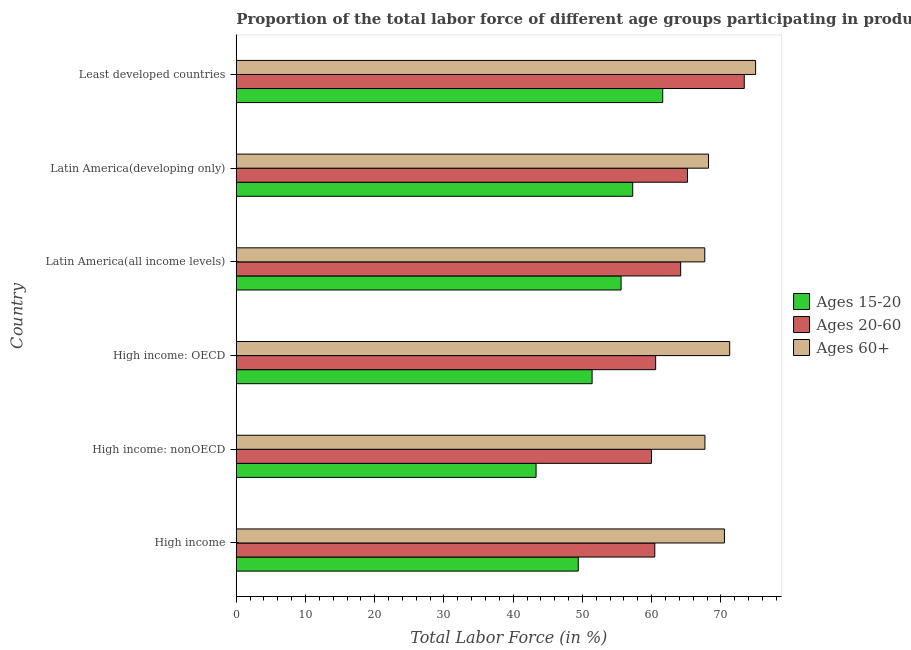How many groups of bars are there?
Offer a terse response. 6. Are the number of bars per tick equal to the number of legend labels?
Give a very brief answer. Yes. How many bars are there on the 3rd tick from the top?
Your response must be concise. 3. How many bars are there on the 6th tick from the bottom?
Offer a terse response. 3. What is the label of the 5th group of bars from the top?
Offer a very short reply. High income: nonOECD. In how many cases, is the number of bars for a given country not equal to the number of legend labels?
Provide a short and direct response. 0. What is the percentage of labor force above age 60 in Latin America(all income levels)?
Your response must be concise. 67.67. Across all countries, what is the maximum percentage of labor force within the age group 15-20?
Provide a succinct answer. 61.6. Across all countries, what is the minimum percentage of labor force within the age group 15-20?
Ensure brevity in your answer.  43.31. In which country was the percentage of labor force within the age group 15-20 maximum?
Your answer should be compact. Least developed countries. In which country was the percentage of labor force within the age group 15-20 minimum?
Ensure brevity in your answer.  High income: nonOECD. What is the total percentage of labor force above age 60 in the graph?
Provide a succinct answer. 420.39. What is the difference between the percentage of labor force above age 60 in Latin America(all income levels) and that in Least developed countries?
Provide a short and direct response. -7.34. What is the difference between the percentage of labor force within the age group 15-20 in High income and the percentage of labor force within the age group 20-60 in High income: nonOECD?
Your response must be concise. -10.57. What is the average percentage of labor force within the age group 20-60 per country?
Your response must be concise. 63.96. What is the difference between the percentage of labor force within the age group 20-60 and percentage of labor force within the age group 15-20 in Latin America(all income levels)?
Ensure brevity in your answer.  8.61. In how many countries, is the percentage of labor force within the age group 15-20 greater than 2 %?
Ensure brevity in your answer.  6. What is the ratio of the percentage of labor force within the age group 20-60 in High income: nonOECD to that in Latin America(all income levels)?
Offer a terse response. 0.93. What is the difference between the highest and the second highest percentage of labor force within the age group 15-20?
Offer a very short reply. 4.33. What is the difference between the highest and the lowest percentage of labor force above age 60?
Make the answer very short. 7.34. In how many countries, is the percentage of labor force within the age group 20-60 greater than the average percentage of labor force within the age group 20-60 taken over all countries?
Offer a terse response. 3. Is the sum of the percentage of labor force above age 60 in High income: nonOECD and Least developed countries greater than the maximum percentage of labor force within the age group 15-20 across all countries?
Provide a short and direct response. Yes. What does the 3rd bar from the top in High income: OECD represents?
Provide a short and direct response. Ages 15-20. What does the 2nd bar from the bottom in Latin America(developing only) represents?
Provide a succinct answer. Ages 20-60. Is it the case that in every country, the sum of the percentage of labor force within the age group 15-20 and percentage of labor force within the age group 20-60 is greater than the percentage of labor force above age 60?
Provide a succinct answer. Yes. How many countries are there in the graph?
Offer a terse response. 6. What is the difference between two consecutive major ticks on the X-axis?
Your response must be concise. 10. Are the values on the major ticks of X-axis written in scientific E-notation?
Ensure brevity in your answer.  No. Does the graph contain any zero values?
Keep it short and to the point. No. Does the graph contain grids?
Keep it short and to the point. No. Where does the legend appear in the graph?
Ensure brevity in your answer.  Center right. How many legend labels are there?
Give a very brief answer. 3. What is the title of the graph?
Keep it short and to the point. Proportion of the total labor force of different age groups participating in production in 1999. Does "Taxes on goods and services" appear as one of the legend labels in the graph?
Offer a very short reply. No. What is the label or title of the X-axis?
Your response must be concise. Total Labor Force (in %). What is the Total Labor Force (in %) in Ages 15-20 in High income?
Provide a succinct answer. 49.4. What is the Total Labor Force (in %) of Ages 20-60 in High income?
Your answer should be very brief. 60.46. What is the Total Labor Force (in %) of Ages 60+ in High income?
Ensure brevity in your answer.  70.51. What is the Total Labor Force (in %) in Ages 15-20 in High income: nonOECD?
Your answer should be very brief. 43.31. What is the Total Labor Force (in %) in Ages 20-60 in High income: nonOECD?
Provide a short and direct response. 59.97. What is the Total Labor Force (in %) of Ages 60+ in High income: nonOECD?
Provide a short and direct response. 67.7. What is the Total Labor Force (in %) of Ages 15-20 in High income: OECD?
Make the answer very short. 51.4. What is the Total Labor Force (in %) in Ages 20-60 in High income: OECD?
Provide a succinct answer. 60.58. What is the Total Labor Force (in %) in Ages 60+ in High income: OECD?
Offer a very short reply. 71.27. What is the Total Labor Force (in %) in Ages 15-20 in Latin America(all income levels)?
Your response must be concise. 55.59. What is the Total Labor Force (in %) of Ages 20-60 in Latin America(all income levels)?
Provide a succinct answer. 64.19. What is the Total Labor Force (in %) of Ages 60+ in Latin America(all income levels)?
Ensure brevity in your answer.  67.67. What is the Total Labor Force (in %) in Ages 15-20 in Latin America(developing only)?
Keep it short and to the point. 57.26. What is the Total Labor Force (in %) in Ages 20-60 in Latin America(developing only)?
Your response must be concise. 65.18. What is the Total Labor Force (in %) of Ages 60+ in Latin America(developing only)?
Make the answer very short. 68.22. What is the Total Labor Force (in %) in Ages 15-20 in Least developed countries?
Offer a terse response. 61.6. What is the Total Labor Force (in %) in Ages 20-60 in Least developed countries?
Offer a terse response. 73.38. What is the Total Labor Force (in %) in Ages 60+ in Least developed countries?
Give a very brief answer. 75.02. Across all countries, what is the maximum Total Labor Force (in %) in Ages 15-20?
Give a very brief answer. 61.6. Across all countries, what is the maximum Total Labor Force (in %) in Ages 20-60?
Give a very brief answer. 73.38. Across all countries, what is the maximum Total Labor Force (in %) in Ages 60+?
Provide a succinct answer. 75.02. Across all countries, what is the minimum Total Labor Force (in %) of Ages 15-20?
Ensure brevity in your answer.  43.31. Across all countries, what is the minimum Total Labor Force (in %) of Ages 20-60?
Ensure brevity in your answer.  59.97. Across all countries, what is the minimum Total Labor Force (in %) in Ages 60+?
Provide a short and direct response. 67.67. What is the total Total Labor Force (in %) in Ages 15-20 in the graph?
Give a very brief answer. 318.57. What is the total Total Labor Force (in %) in Ages 20-60 in the graph?
Provide a succinct answer. 383.77. What is the total Total Labor Force (in %) of Ages 60+ in the graph?
Your answer should be compact. 420.39. What is the difference between the Total Labor Force (in %) of Ages 15-20 in High income and that in High income: nonOECD?
Give a very brief answer. 6.09. What is the difference between the Total Labor Force (in %) of Ages 20-60 in High income and that in High income: nonOECD?
Make the answer very short. 0.48. What is the difference between the Total Labor Force (in %) of Ages 60+ in High income and that in High income: nonOECD?
Offer a very short reply. 2.82. What is the difference between the Total Labor Force (in %) in Ages 15-20 in High income and that in High income: OECD?
Make the answer very short. -2. What is the difference between the Total Labor Force (in %) in Ages 20-60 in High income and that in High income: OECD?
Give a very brief answer. -0.12. What is the difference between the Total Labor Force (in %) in Ages 60+ in High income and that in High income: OECD?
Make the answer very short. -0.76. What is the difference between the Total Labor Force (in %) of Ages 15-20 in High income and that in Latin America(all income levels)?
Ensure brevity in your answer.  -6.19. What is the difference between the Total Labor Force (in %) of Ages 20-60 in High income and that in Latin America(all income levels)?
Offer a terse response. -3.74. What is the difference between the Total Labor Force (in %) of Ages 60+ in High income and that in Latin America(all income levels)?
Offer a terse response. 2.84. What is the difference between the Total Labor Force (in %) in Ages 15-20 in High income and that in Latin America(developing only)?
Offer a terse response. -7.86. What is the difference between the Total Labor Force (in %) of Ages 20-60 in High income and that in Latin America(developing only)?
Give a very brief answer. -4.73. What is the difference between the Total Labor Force (in %) of Ages 60+ in High income and that in Latin America(developing only)?
Make the answer very short. 2.3. What is the difference between the Total Labor Force (in %) in Ages 15-20 in High income and that in Least developed countries?
Your answer should be compact. -12.2. What is the difference between the Total Labor Force (in %) in Ages 20-60 in High income and that in Least developed countries?
Your answer should be very brief. -12.92. What is the difference between the Total Labor Force (in %) of Ages 60+ in High income and that in Least developed countries?
Your answer should be very brief. -4.5. What is the difference between the Total Labor Force (in %) of Ages 15-20 in High income: nonOECD and that in High income: OECD?
Offer a very short reply. -8.09. What is the difference between the Total Labor Force (in %) of Ages 20-60 in High income: nonOECD and that in High income: OECD?
Keep it short and to the point. -0.61. What is the difference between the Total Labor Force (in %) in Ages 60+ in High income: nonOECD and that in High income: OECD?
Offer a very short reply. -3.58. What is the difference between the Total Labor Force (in %) in Ages 15-20 in High income: nonOECD and that in Latin America(all income levels)?
Offer a very short reply. -12.28. What is the difference between the Total Labor Force (in %) of Ages 20-60 in High income: nonOECD and that in Latin America(all income levels)?
Your answer should be very brief. -4.22. What is the difference between the Total Labor Force (in %) of Ages 60+ in High income: nonOECD and that in Latin America(all income levels)?
Offer a terse response. 0.02. What is the difference between the Total Labor Force (in %) of Ages 15-20 in High income: nonOECD and that in Latin America(developing only)?
Ensure brevity in your answer.  -13.96. What is the difference between the Total Labor Force (in %) of Ages 20-60 in High income: nonOECD and that in Latin America(developing only)?
Your response must be concise. -5.21. What is the difference between the Total Labor Force (in %) in Ages 60+ in High income: nonOECD and that in Latin America(developing only)?
Make the answer very short. -0.52. What is the difference between the Total Labor Force (in %) of Ages 15-20 in High income: nonOECD and that in Least developed countries?
Ensure brevity in your answer.  -18.29. What is the difference between the Total Labor Force (in %) of Ages 20-60 in High income: nonOECD and that in Least developed countries?
Your answer should be compact. -13.41. What is the difference between the Total Labor Force (in %) of Ages 60+ in High income: nonOECD and that in Least developed countries?
Give a very brief answer. -7.32. What is the difference between the Total Labor Force (in %) of Ages 15-20 in High income: OECD and that in Latin America(all income levels)?
Give a very brief answer. -4.19. What is the difference between the Total Labor Force (in %) in Ages 20-60 in High income: OECD and that in Latin America(all income levels)?
Your response must be concise. -3.62. What is the difference between the Total Labor Force (in %) of Ages 60+ in High income: OECD and that in Latin America(all income levels)?
Your answer should be very brief. 3.6. What is the difference between the Total Labor Force (in %) of Ages 15-20 in High income: OECD and that in Latin America(developing only)?
Make the answer very short. -5.86. What is the difference between the Total Labor Force (in %) in Ages 20-60 in High income: OECD and that in Latin America(developing only)?
Your response must be concise. -4.6. What is the difference between the Total Labor Force (in %) of Ages 60+ in High income: OECD and that in Latin America(developing only)?
Ensure brevity in your answer.  3.06. What is the difference between the Total Labor Force (in %) in Ages 15-20 in High income: OECD and that in Least developed countries?
Provide a short and direct response. -10.2. What is the difference between the Total Labor Force (in %) in Ages 20-60 in High income: OECD and that in Least developed countries?
Keep it short and to the point. -12.8. What is the difference between the Total Labor Force (in %) of Ages 60+ in High income: OECD and that in Least developed countries?
Offer a terse response. -3.74. What is the difference between the Total Labor Force (in %) in Ages 15-20 in Latin America(all income levels) and that in Latin America(developing only)?
Keep it short and to the point. -1.68. What is the difference between the Total Labor Force (in %) in Ages 20-60 in Latin America(all income levels) and that in Latin America(developing only)?
Ensure brevity in your answer.  -0.99. What is the difference between the Total Labor Force (in %) of Ages 60+ in Latin America(all income levels) and that in Latin America(developing only)?
Your answer should be very brief. -0.54. What is the difference between the Total Labor Force (in %) of Ages 15-20 in Latin America(all income levels) and that in Least developed countries?
Provide a succinct answer. -6.01. What is the difference between the Total Labor Force (in %) in Ages 20-60 in Latin America(all income levels) and that in Least developed countries?
Your response must be concise. -9.19. What is the difference between the Total Labor Force (in %) of Ages 60+ in Latin America(all income levels) and that in Least developed countries?
Your response must be concise. -7.34. What is the difference between the Total Labor Force (in %) of Ages 15-20 in Latin America(developing only) and that in Least developed countries?
Give a very brief answer. -4.34. What is the difference between the Total Labor Force (in %) of Ages 20-60 in Latin America(developing only) and that in Least developed countries?
Make the answer very short. -8.2. What is the difference between the Total Labor Force (in %) of Ages 60+ in Latin America(developing only) and that in Least developed countries?
Offer a very short reply. -6.8. What is the difference between the Total Labor Force (in %) in Ages 15-20 in High income and the Total Labor Force (in %) in Ages 20-60 in High income: nonOECD?
Your answer should be very brief. -10.57. What is the difference between the Total Labor Force (in %) in Ages 15-20 in High income and the Total Labor Force (in %) in Ages 60+ in High income: nonOECD?
Offer a terse response. -18.29. What is the difference between the Total Labor Force (in %) in Ages 20-60 in High income and the Total Labor Force (in %) in Ages 60+ in High income: nonOECD?
Keep it short and to the point. -7.24. What is the difference between the Total Labor Force (in %) of Ages 15-20 in High income and the Total Labor Force (in %) of Ages 20-60 in High income: OECD?
Offer a very short reply. -11.18. What is the difference between the Total Labor Force (in %) of Ages 15-20 in High income and the Total Labor Force (in %) of Ages 60+ in High income: OECD?
Make the answer very short. -21.87. What is the difference between the Total Labor Force (in %) of Ages 20-60 in High income and the Total Labor Force (in %) of Ages 60+ in High income: OECD?
Your answer should be very brief. -10.82. What is the difference between the Total Labor Force (in %) of Ages 15-20 in High income and the Total Labor Force (in %) of Ages 20-60 in Latin America(all income levels)?
Provide a succinct answer. -14.79. What is the difference between the Total Labor Force (in %) in Ages 15-20 in High income and the Total Labor Force (in %) in Ages 60+ in Latin America(all income levels)?
Ensure brevity in your answer.  -18.27. What is the difference between the Total Labor Force (in %) in Ages 20-60 in High income and the Total Labor Force (in %) in Ages 60+ in Latin America(all income levels)?
Make the answer very short. -7.22. What is the difference between the Total Labor Force (in %) in Ages 15-20 in High income and the Total Labor Force (in %) in Ages 20-60 in Latin America(developing only)?
Your response must be concise. -15.78. What is the difference between the Total Labor Force (in %) in Ages 15-20 in High income and the Total Labor Force (in %) in Ages 60+ in Latin America(developing only)?
Keep it short and to the point. -18.81. What is the difference between the Total Labor Force (in %) of Ages 20-60 in High income and the Total Labor Force (in %) of Ages 60+ in Latin America(developing only)?
Ensure brevity in your answer.  -7.76. What is the difference between the Total Labor Force (in %) in Ages 15-20 in High income and the Total Labor Force (in %) in Ages 20-60 in Least developed countries?
Keep it short and to the point. -23.98. What is the difference between the Total Labor Force (in %) of Ages 15-20 in High income and the Total Labor Force (in %) of Ages 60+ in Least developed countries?
Ensure brevity in your answer.  -25.61. What is the difference between the Total Labor Force (in %) of Ages 20-60 in High income and the Total Labor Force (in %) of Ages 60+ in Least developed countries?
Offer a very short reply. -14.56. What is the difference between the Total Labor Force (in %) of Ages 15-20 in High income: nonOECD and the Total Labor Force (in %) of Ages 20-60 in High income: OECD?
Your response must be concise. -17.27. What is the difference between the Total Labor Force (in %) in Ages 15-20 in High income: nonOECD and the Total Labor Force (in %) in Ages 60+ in High income: OECD?
Give a very brief answer. -27.97. What is the difference between the Total Labor Force (in %) of Ages 20-60 in High income: nonOECD and the Total Labor Force (in %) of Ages 60+ in High income: OECD?
Provide a succinct answer. -11.3. What is the difference between the Total Labor Force (in %) of Ages 15-20 in High income: nonOECD and the Total Labor Force (in %) of Ages 20-60 in Latin America(all income levels)?
Your answer should be very brief. -20.89. What is the difference between the Total Labor Force (in %) in Ages 15-20 in High income: nonOECD and the Total Labor Force (in %) in Ages 60+ in Latin America(all income levels)?
Keep it short and to the point. -24.37. What is the difference between the Total Labor Force (in %) in Ages 20-60 in High income: nonOECD and the Total Labor Force (in %) in Ages 60+ in Latin America(all income levels)?
Ensure brevity in your answer.  -7.7. What is the difference between the Total Labor Force (in %) in Ages 15-20 in High income: nonOECD and the Total Labor Force (in %) in Ages 20-60 in Latin America(developing only)?
Keep it short and to the point. -21.87. What is the difference between the Total Labor Force (in %) in Ages 15-20 in High income: nonOECD and the Total Labor Force (in %) in Ages 60+ in Latin America(developing only)?
Ensure brevity in your answer.  -24.91. What is the difference between the Total Labor Force (in %) of Ages 20-60 in High income: nonOECD and the Total Labor Force (in %) of Ages 60+ in Latin America(developing only)?
Offer a very short reply. -8.24. What is the difference between the Total Labor Force (in %) of Ages 15-20 in High income: nonOECD and the Total Labor Force (in %) of Ages 20-60 in Least developed countries?
Give a very brief answer. -30.07. What is the difference between the Total Labor Force (in %) in Ages 15-20 in High income: nonOECD and the Total Labor Force (in %) in Ages 60+ in Least developed countries?
Keep it short and to the point. -31.71. What is the difference between the Total Labor Force (in %) of Ages 20-60 in High income: nonOECD and the Total Labor Force (in %) of Ages 60+ in Least developed countries?
Offer a terse response. -15.04. What is the difference between the Total Labor Force (in %) in Ages 15-20 in High income: OECD and the Total Labor Force (in %) in Ages 20-60 in Latin America(all income levels)?
Provide a short and direct response. -12.79. What is the difference between the Total Labor Force (in %) of Ages 15-20 in High income: OECD and the Total Labor Force (in %) of Ages 60+ in Latin America(all income levels)?
Provide a succinct answer. -16.27. What is the difference between the Total Labor Force (in %) in Ages 20-60 in High income: OECD and the Total Labor Force (in %) in Ages 60+ in Latin America(all income levels)?
Keep it short and to the point. -7.09. What is the difference between the Total Labor Force (in %) of Ages 15-20 in High income: OECD and the Total Labor Force (in %) of Ages 20-60 in Latin America(developing only)?
Ensure brevity in your answer.  -13.78. What is the difference between the Total Labor Force (in %) in Ages 15-20 in High income: OECD and the Total Labor Force (in %) in Ages 60+ in Latin America(developing only)?
Offer a terse response. -16.81. What is the difference between the Total Labor Force (in %) of Ages 20-60 in High income: OECD and the Total Labor Force (in %) of Ages 60+ in Latin America(developing only)?
Ensure brevity in your answer.  -7.64. What is the difference between the Total Labor Force (in %) in Ages 15-20 in High income: OECD and the Total Labor Force (in %) in Ages 20-60 in Least developed countries?
Offer a very short reply. -21.98. What is the difference between the Total Labor Force (in %) in Ages 15-20 in High income: OECD and the Total Labor Force (in %) in Ages 60+ in Least developed countries?
Your answer should be compact. -23.61. What is the difference between the Total Labor Force (in %) of Ages 20-60 in High income: OECD and the Total Labor Force (in %) of Ages 60+ in Least developed countries?
Your answer should be compact. -14.44. What is the difference between the Total Labor Force (in %) of Ages 15-20 in Latin America(all income levels) and the Total Labor Force (in %) of Ages 20-60 in Latin America(developing only)?
Provide a short and direct response. -9.59. What is the difference between the Total Labor Force (in %) of Ages 15-20 in Latin America(all income levels) and the Total Labor Force (in %) of Ages 60+ in Latin America(developing only)?
Your answer should be very brief. -12.63. What is the difference between the Total Labor Force (in %) of Ages 20-60 in Latin America(all income levels) and the Total Labor Force (in %) of Ages 60+ in Latin America(developing only)?
Offer a terse response. -4.02. What is the difference between the Total Labor Force (in %) of Ages 15-20 in Latin America(all income levels) and the Total Labor Force (in %) of Ages 20-60 in Least developed countries?
Your answer should be very brief. -17.79. What is the difference between the Total Labor Force (in %) in Ages 15-20 in Latin America(all income levels) and the Total Labor Force (in %) in Ages 60+ in Least developed countries?
Your answer should be compact. -19.43. What is the difference between the Total Labor Force (in %) in Ages 20-60 in Latin America(all income levels) and the Total Labor Force (in %) in Ages 60+ in Least developed countries?
Your response must be concise. -10.82. What is the difference between the Total Labor Force (in %) in Ages 15-20 in Latin America(developing only) and the Total Labor Force (in %) in Ages 20-60 in Least developed countries?
Give a very brief answer. -16.12. What is the difference between the Total Labor Force (in %) of Ages 15-20 in Latin America(developing only) and the Total Labor Force (in %) of Ages 60+ in Least developed countries?
Offer a very short reply. -17.75. What is the difference between the Total Labor Force (in %) in Ages 20-60 in Latin America(developing only) and the Total Labor Force (in %) in Ages 60+ in Least developed countries?
Keep it short and to the point. -9.83. What is the average Total Labor Force (in %) of Ages 15-20 per country?
Your response must be concise. 53.09. What is the average Total Labor Force (in %) in Ages 20-60 per country?
Your answer should be compact. 63.96. What is the average Total Labor Force (in %) of Ages 60+ per country?
Offer a very short reply. 70.06. What is the difference between the Total Labor Force (in %) of Ages 15-20 and Total Labor Force (in %) of Ages 20-60 in High income?
Your answer should be very brief. -11.05. What is the difference between the Total Labor Force (in %) in Ages 15-20 and Total Labor Force (in %) in Ages 60+ in High income?
Your answer should be very brief. -21.11. What is the difference between the Total Labor Force (in %) of Ages 20-60 and Total Labor Force (in %) of Ages 60+ in High income?
Keep it short and to the point. -10.06. What is the difference between the Total Labor Force (in %) in Ages 15-20 and Total Labor Force (in %) in Ages 20-60 in High income: nonOECD?
Provide a short and direct response. -16.67. What is the difference between the Total Labor Force (in %) in Ages 15-20 and Total Labor Force (in %) in Ages 60+ in High income: nonOECD?
Provide a succinct answer. -24.39. What is the difference between the Total Labor Force (in %) of Ages 20-60 and Total Labor Force (in %) of Ages 60+ in High income: nonOECD?
Your answer should be compact. -7.72. What is the difference between the Total Labor Force (in %) in Ages 15-20 and Total Labor Force (in %) in Ages 20-60 in High income: OECD?
Your answer should be compact. -9.18. What is the difference between the Total Labor Force (in %) in Ages 15-20 and Total Labor Force (in %) in Ages 60+ in High income: OECD?
Your answer should be compact. -19.87. What is the difference between the Total Labor Force (in %) in Ages 20-60 and Total Labor Force (in %) in Ages 60+ in High income: OECD?
Offer a very short reply. -10.69. What is the difference between the Total Labor Force (in %) in Ages 15-20 and Total Labor Force (in %) in Ages 20-60 in Latin America(all income levels)?
Your answer should be compact. -8.61. What is the difference between the Total Labor Force (in %) of Ages 15-20 and Total Labor Force (in %) of Ages 60+ in Latin America(all income levels)?
Your answer should be very brief. -12.09. What is the difference between the Total Labor Force (in %) in Ages 20-60 and Total Labor Force (in %) in Ages 60+ in Latin America(all income levels)?
Make the answer very short. -3.48. What is the difference between the Total Labor Force (in %) of Ages 15-20 and Total Labor Force (in %) of Ages 20-60 in Latin America(developing only)?
Provide a short and direct response. -7.92. What is the difference between the Total Labor Force (in %) in Ages 15-20 and Total Labor Force (in %) in Ages 60+ in Latin America(developing only)?
Give a very brief answer. -10.95. What is the difference between the Total Labor Force (in %) of Ages 20-60 and Total Labor Force (in %) of Ages 60+ in Latin America(developing only)?
Offer a very short reply. -3.04. What is the difference between the Total Labor Force (in %) in Ages 15-20 and Total Labor Force (in %) in Ages 20-60 in Least developed countries?
Give a very brief answer. -11.78. What is the difference between the Total Labor Force (in %) of Ages 15-20 and Total Labor Force (in %) of Ages 60+ in Least developed countries?
Offer a terse response. -13.42. What is the difference between the Total Labor Force (in %) in Ages 20-60 and Total Labor Force (in %) in Ages 60+ in Least developed countries?
Give a very brief answer. -1.64. What is the ratio of the Total Labor Force (in %) in Ages 15-20 in High income to that in High income: nonOECD?
Your answer should be very brief. 1.14. What is the ratio of the Total Labor Force (in %) in Ages 60+ in High income to that in High income: nonOECD?
Your answer should be very brief. 1.04. What is the ratio of the Total Labor Force (in %) of Ages 15-20 in High income to that in High income: OECD?
Provide a short and direct response. 0.96. What is the ratio of the Total Labor Force (in %) of Ages 20-60 in High income to that in High income: OECD?
Make the answer very short. 1. What is the ratio of the Total Labor Force (in %) in Ages 60+ in High income to that in High income: OECD?
Your answer should be compact. 0.99. What is the ratio of the Total Labor Force (in %) in Ages 15-20 in High income to that in Latin America(all income levels)?
Provide a short and direct response. 0.89. What is the ratio of the Total Labor Force (in %) in Ages 20-60 in High income to that in Latin America(all income levels)?
Your response must be concise. 0.94. What is the ratio of the Total Labor Force (in %) of Ages 60+ in High income to that in Latin America(all income levels)?
Your answer should be very brief. 1.04. What is the ratio of the Total Labor Force (in %) of Ages 15-20 in High income to that in Latin America(developing only)?
Ensure brevity in your answer.  0.86. What is the ratio of the Total Labor Force (in %) in Ages 20-60 in High income to that in Latin America(developing only)?
Make the answer very short. 0.93. What is the ratio of the Total Labor Force (in %) in Ages 60+ in High income to that in Latin America(developing only)?
Your response must be concise. 1.03. What is the ratio of the Total Labor Force (in %) of Ages 15-20 in High income to that in Least developed countries?
Your answer should be very brief. 0.8. What is the ratio of the Total Labor Force (in %) in Ages 20-60 in High income to that in Least developed countries?
Your answer should be compact. 0.82. What is the ratio of the Total Labor Force (in %) of Ages 60+ in High income to that in Least developed countries?
Offer a very short reply. 0.94. What is the ratio of the Total Labor Force (in %) of Ages 15-20 in High income: nonOECD to that in High income: OECD?
Provide a succinct answer. 0.84. What is the ratio of the Total Labor Force (in %) of Ages 60+ in High income: nonOECD to that in High income: OECD?
Ensure brevity in your answer.  0.95. What is the ratio of the Total Labor Force (in %) in Ages 15-20 in High income: nonOECD to that in Latin America(all income levels)?
Your answer should be compact. 0.78. What is the ratio of the Total Labor Force (in %) of Ages 20-60 in High income: nonOECD to that in Latin America(all income levels)?
Offer a very short reply. 0.93. What is the ratio of the Total Labor Force (in %) in Ages 60+ in High income: nonOECD to that in Latin America(all income levels)?
Ensure brevity in your answer.  1. What is the ratio of the Total Labor Force (in %) of Ages 15-20 in High income: nonOECD to that in Latin America(developing only)?
Give a very brief answer. 0.76. What is the ratio of the Total Labor Force (in %) of Ages 20-60 in High income: nonOECD to that in Latin America(developing only)?
Keep it short and to the point. 0.92. What is the ratio of the Total Labor Force (in %) of Ages 60+ in High income: nonOECD to that in Latin America(developing only)?
Make the answer very short. 0.99. What is the ratio of the Total Labor Force (in %) in Ages 15-20 in High income: nonOECD to that in Least developed countries?
Your response must be concise. 0.7. What is the ratio of the Total Labor Force (in %) of Ages 20-60 in High income: nonOECD to that in Least developed countries?
Give a very brief answer. 0.82. What is the ratio of the Total Labor Force (in %) of Ages 60+ in High income: nonOECD to that in Least developed countries?
Your response must be concise. 0.9. What is the ratio of the Total Labor Force (in %) in Ages 15-20 in High income: OECD to that in Latin America(all income levels)?
Give a very brief answer. 0.92. What is the ratio of the Total Labor Force (in %) in Ages 20-60 in High income: OECD to that in Latin America(all income levels)?
Provide a short and direct response. 0.94. What is the ratio of the Total Labor Force (in %) in Ages 60+ in High income: OECD to that in Latin America(all income levels)?
Your response must be concise. 1.05. What is the ratio of the Total Labor Force (in %) in Ages 15-20 in High income: OECD to that in Latin America(developing only)?
Keep it short and to the point. 0.9. What is the ratio of the Total Labor Force (in %) of Ages 20-60 in High income: OECD to that in Latin America(developing only)?
Make the answer very short. 0.93. What is the ratio of the Total Labor Force (in %) of Ages 60+ in High income: OECD to that in Latin America(developing only)?
Offer a very short reply. 1.04. What is the ratio of the Total Labor Force (in %) of Ages 15-20 in High income: OECD to that in Least developed countries?
Your response must be concise. 0.83. What is the ratio of the Total Labor Force (in %) in Ages 20-60 in High income: OECD to that in Least developed countries?
Offer a very short reply. 0.83. What is the ratio of the Total Labor Force (in %) of Ages 60+ in High income: OECD to that in Least developed countries?
Give a very brief answer. 0.95. What is the ratio of the Total Labor Force (in %) of Ages 15-20 in Latin America(all income levels) to that in Latin America(developing only)?
Provide a short and direct response. 0.97. What is the ratio of the Total Labor Force (in %) in Ages 20-60 in Latin America(all income levels) to that in Latin America(developing only)?
Your response must be concise. 0.98. What is the ratio of the Total Labor Force (in %) of Ages 60+ in Latin America(all income levels) to that in Latin America(developing only)?
Keep it short and to the point. 0.99. What is the ratio of the Total Labor Force (in %) of Ages 15-20 in Latin America(all income levels) to that in Least developed countries?
Your answer should be compact. 0.9. What is the ratio of the Total Labor Force (in %) in Ages 20-60 in Latin America(all income levels) to that in Least developed countries?
Offer a terse response. 0.87. What is the ratio of the Total Labor Force (in %) of Ages 60+ in Latin America(all income levels) to that in Least developed countries?
Provide a short and direct response. 0.9. What is the ratio of the Total Labor Force (in %) of Ages 15-20 in Latin America(developing only) to that in Least developed countries?
Make the answer very short. 0.93. What is the ratio of the Total Labor Force (in %) in Ages 20-60 in Latin America(developing only) to that in Least developed countries?
Make the answer very short. 0.89. What is the ratio of the Total Labor Force (in %) in Ages 60+ in Latin America(developing only) to that in Least developed countries?
Provide a succinct answer. 0.91. What is the difference between the highest and the second highest Total Labor Force (in %) of Ages 15-20?
Make the answer very short. 4.34. What is the difference between the highest and the second highest Total Labor Force (in %) of Ages 20-60?
Ensure brevity in your answer.  8.2. What is the difference between the highest and the second highest Total Labor Force (in %) of Ages 60+?
Make the answer very short. 3.74. What is the difference between the highest and the lowest Total Labor Force (in %) in Ages 15-20?
Keep it short and to the point. 18.29. What is the difference between the highest and the lowest Total Labor Force (in %) of Ages 20-60?
Provide a succinct answer. 13.41. What is the difference between the highest and the lowest Total Labor Force (in %) in Ages 60+?
Offer a terse response. 7.34. 